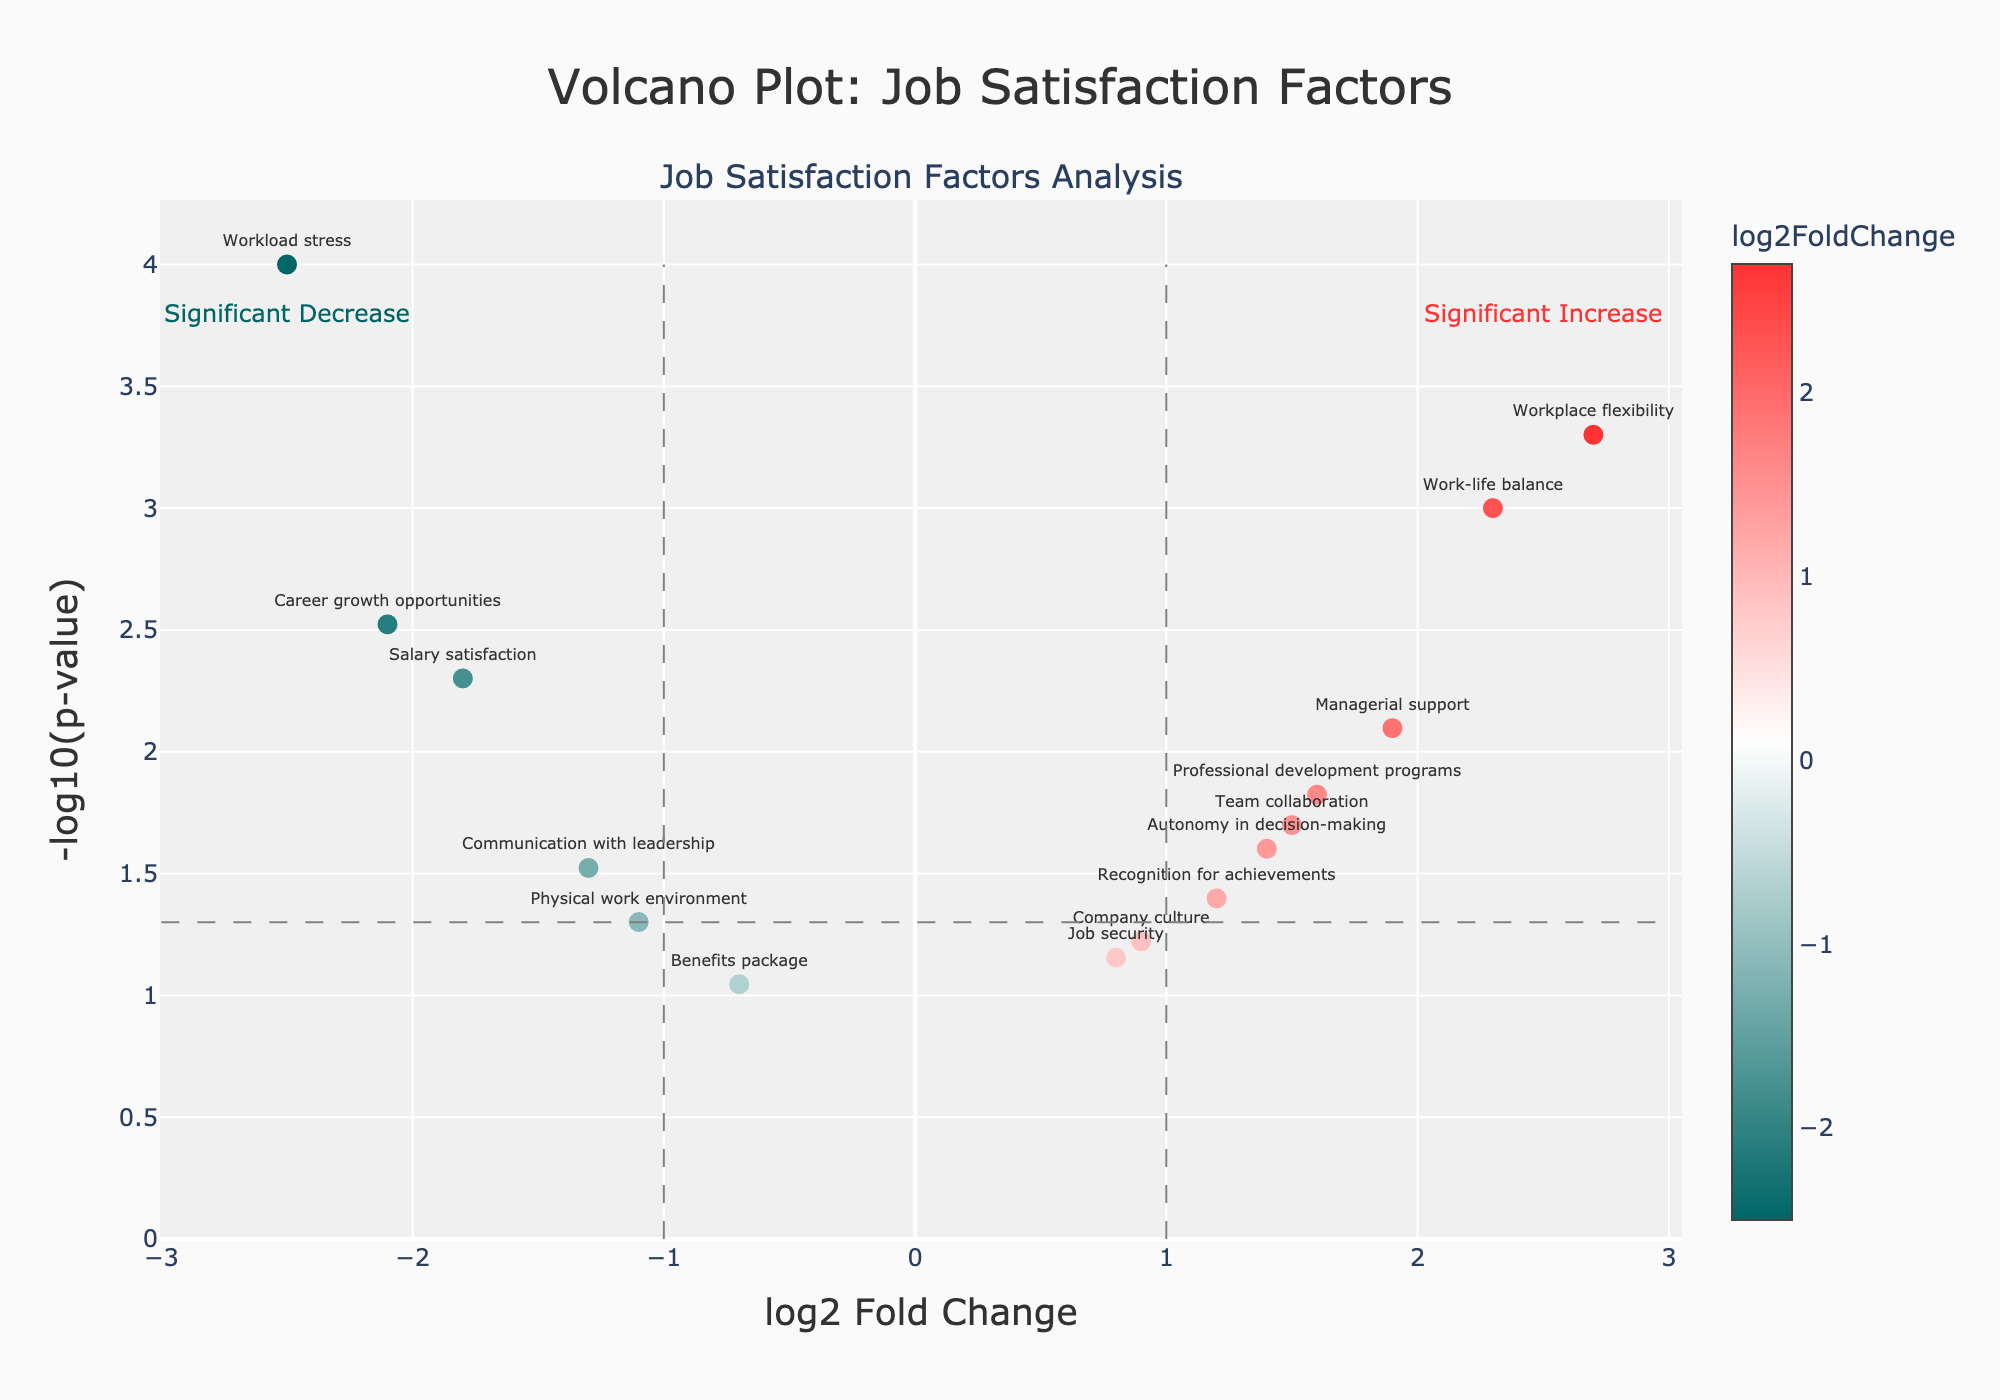What is the title of the plot? The title of the plot is located at the top center of the figure. It reads "Volcano Plot: Job Satisfaction Factors".
Answer: Volcano Plot: Job Satisfaction Factors How many data points are above the significance threshold of -log10(p-value) = 1.3? Count the number of points whose -log10(p-value) is above 1.3. There are 11 such points.
Answer: 11 Which factor has the highest log2 fold change? Locate the data point with the highest (rightmost) value on the x-axis. "Workplace flexibility" has the highest log2 fold change of 2.7.
Answer: Workplace flexibility Which factor has the most significant p-value? The most significant p-value will have the highest -log10(p-value). "Workload stress" has the highest -log10(p-value) value.
Answer: Workload stress Which factors show a significant decrease in satisfaction? Factors with negative log2 fold change less than -1 and -log10(p-value) above 1.3 show a significant decrease. These are "Salary satisfaction", "Career growth opportunities", "Workload stress", "Communication with leadership", and "Physical work environment".
Answer: Salary satisfaction, Career growth opportunities, Workload stress, Communication with leadership, Physical work environment What is the log2 fold change and p-value for "Team collaboration"? Refer to the corresponding data point on the plot or hover text for "Team collaboration". The log2 fold change for "Team collaboration" is 1.5, and the p-value is 0.02.
Answer: 1.5, 0.02 Which factors have a -log10(p-value) between 1 and 2? Identify points in this range by looking between the y-axis values of 1 and 2. The factors are "Team collaboration", "Professional development programs", "Autonomy in decision-making", and "Communication with leadership".
Answer: Team collaboration, Professional development programs, Autonomy in decision-making, Communication with leadership How many factors show a significant increase in job satisfaction? Factors with a log2 fold change greater than 1 and -log10(p-value) above 1.3 show a significant increase. There are 5 such factors.
Answer: 5 Which factor has a log2 fold change very close to zero and a p-value greater than 0.05? Identify points near the zero mark on the x-axis and a p-value above 0.05. "Job security" and "Company culture" fit these criteria.
Answer: Job security, Company culture 